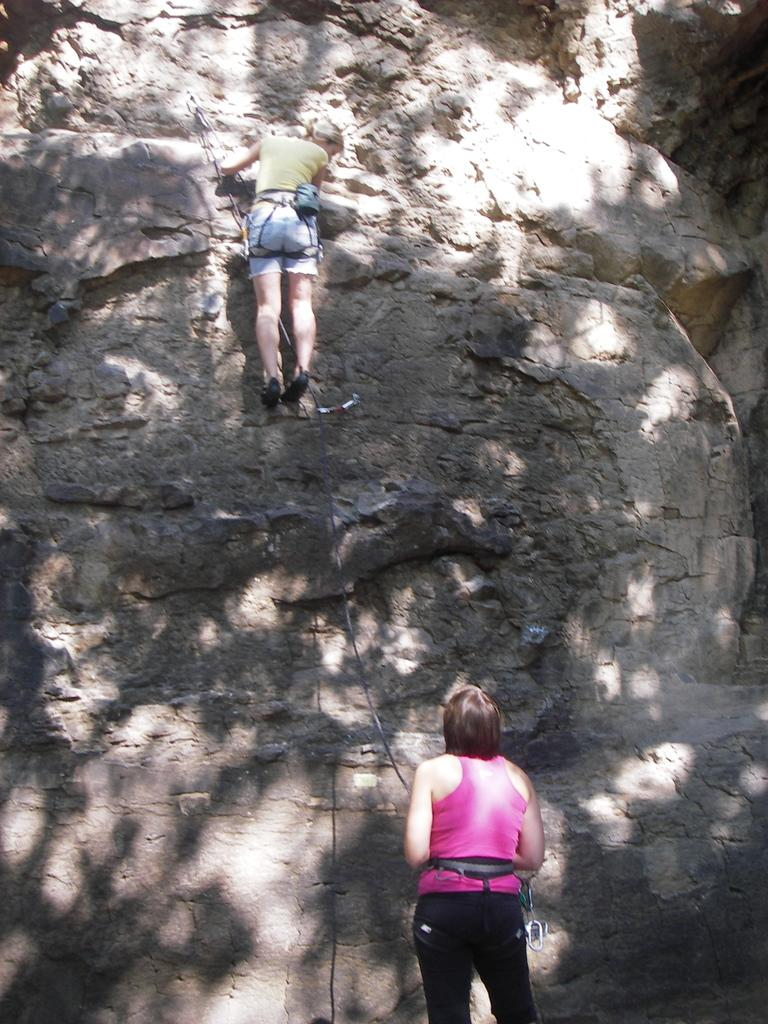What is the main activity taking place in the image? There is a person climbing a mountain in the image. Can you describe the position of the other person in the image? There is another person at the bottom of the mountain in the image. What might the person at the bottom of the mountain be doing or thinking? It is not possible to determine the exact thoughts or actions of the person at the bottom of the mountain, but they might be observing the climber or waiting for them. What advice does the person at the bottom of the mountain give to the climber in the image? There is no dialogue or communication between the two people in the image, so it is not possible to determine the advice given by the person at the bottom of the mountain. 